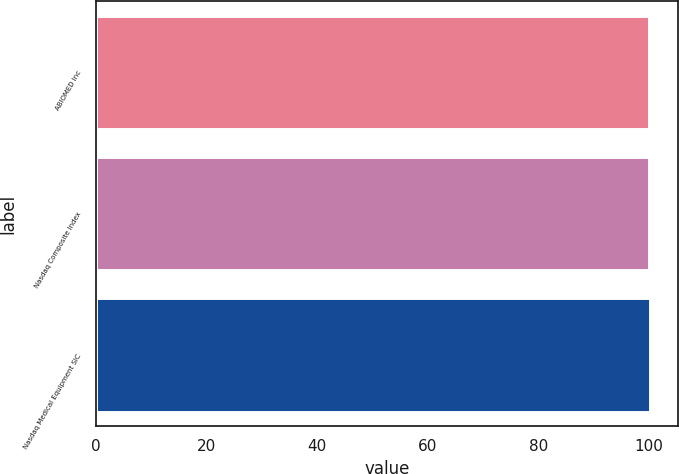Convert chart. <chart><loc_0><loc_0><loc_500><loc_500><bar_chart><fcel>ABIOMED Inc<fcel>Nasdaq Composite Index<fcel>Nasdaq Medical Equipment SIC<nl><fcel>100<fcel>100.1<fcel>100.2<nl></chart> 